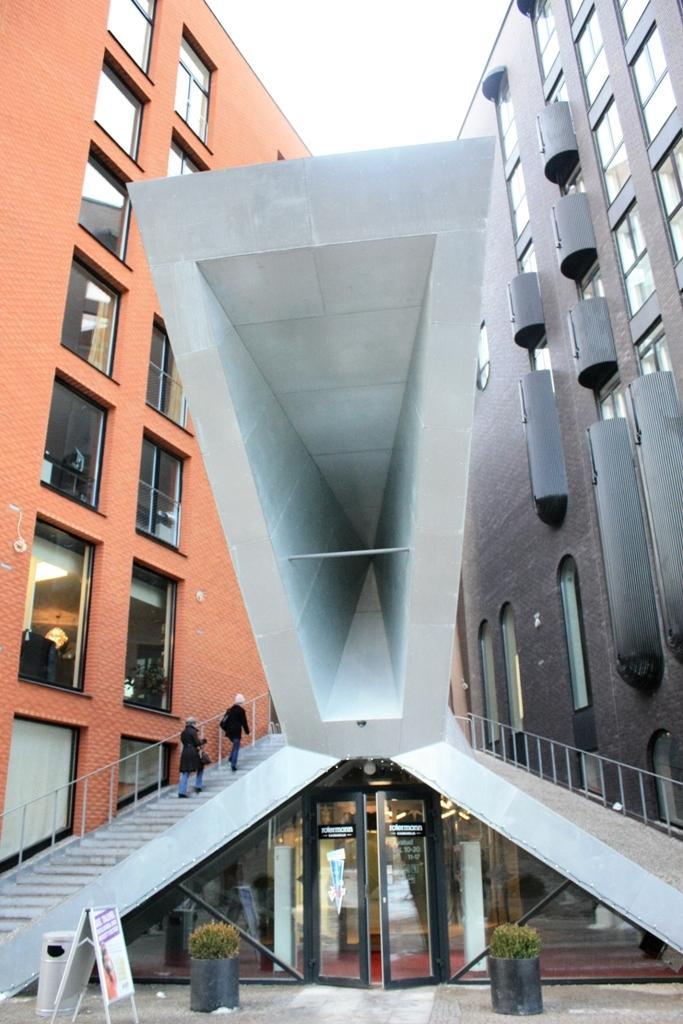How would you summarize this image in a sentence or two? In front of the image there are flower pots. There are glass doors, trash can and a board. At the bottom of the image there are mats on the surface. On the left side of the image there are two people walking on the stairs. There are railings. In the background of the image there are buildings, glass windows. At the top of the image there is sky. 